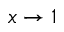Convert formula to latex. <formula><loc_0><loc_0><loc_500><loc_500>x \rightarrow 1</formula> 